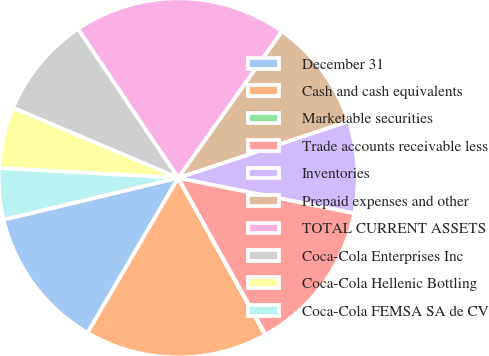<chart> <loc_0><loc_0><loc_500><loc_500><pie_chart><fcel>December 31<fcel>Cash and cash equivalents<fcel>Marketable securities<fcel>Trade accounts receivable less<fcel>Inventories<fcel>Prepaid expenses and other<fcel>TOTAL CURRENT ASSETS<fcel>Coca-Cola Enterprises Inc<fcel>Coca-Cola Hellenic Bottling<fcel>Coca-Cola FEMSA SA de CV<nl><fcel>12.83%<fcel>16.49%<fcel>0.04%<fcel>13.75%<fcel>8.26%<fcel>10.09%<fcel>19.23%<fcel>9.18%<fcel>5.52%<fcel>4.61%<nl></chart> 